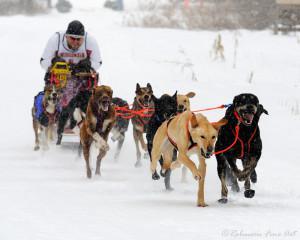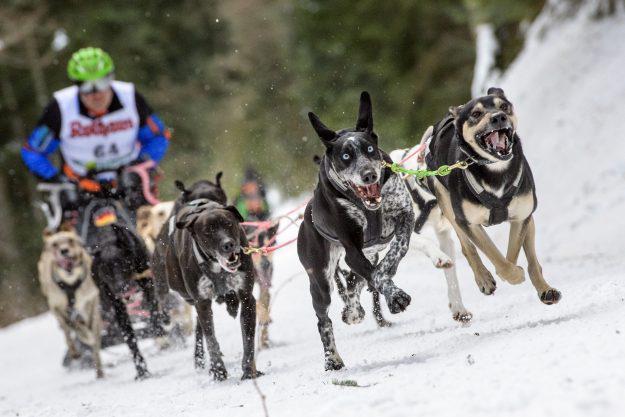The first image is the image on the left, the second image is the image on the right. Examine the images to the left and right. Is the description "A team of dogs wear the same non-black color of booties." accurate? Answer yes or no. No. The first image is the image on the left, the second image is the image on the right. Analyze the images presented: Is the assertion "Some dogs are wearing gloves that aren't black." valid? Answer yes or no. No. 